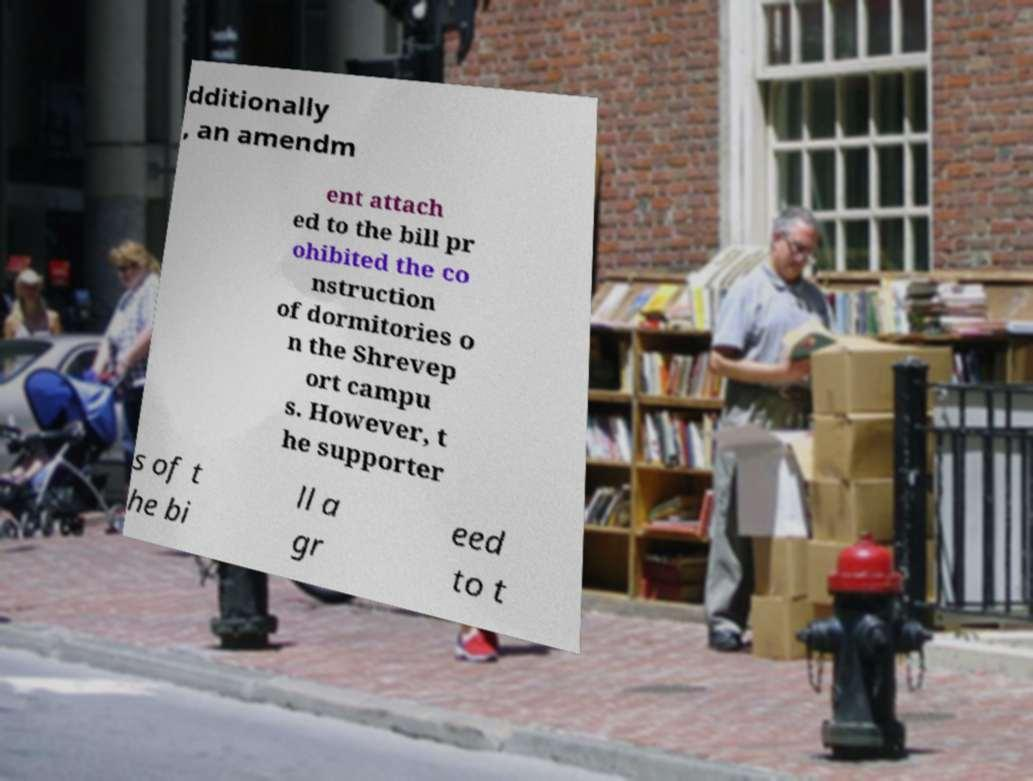Could you assist in decoding the text presented in this image and type it out clearly? dditionally , an amendm ent attach ed to the bill pr ohibited the co nstruction of dormitories o n the Shrevep ort campu s. However, t he supporter s of t he bi ll a gr eed to t 